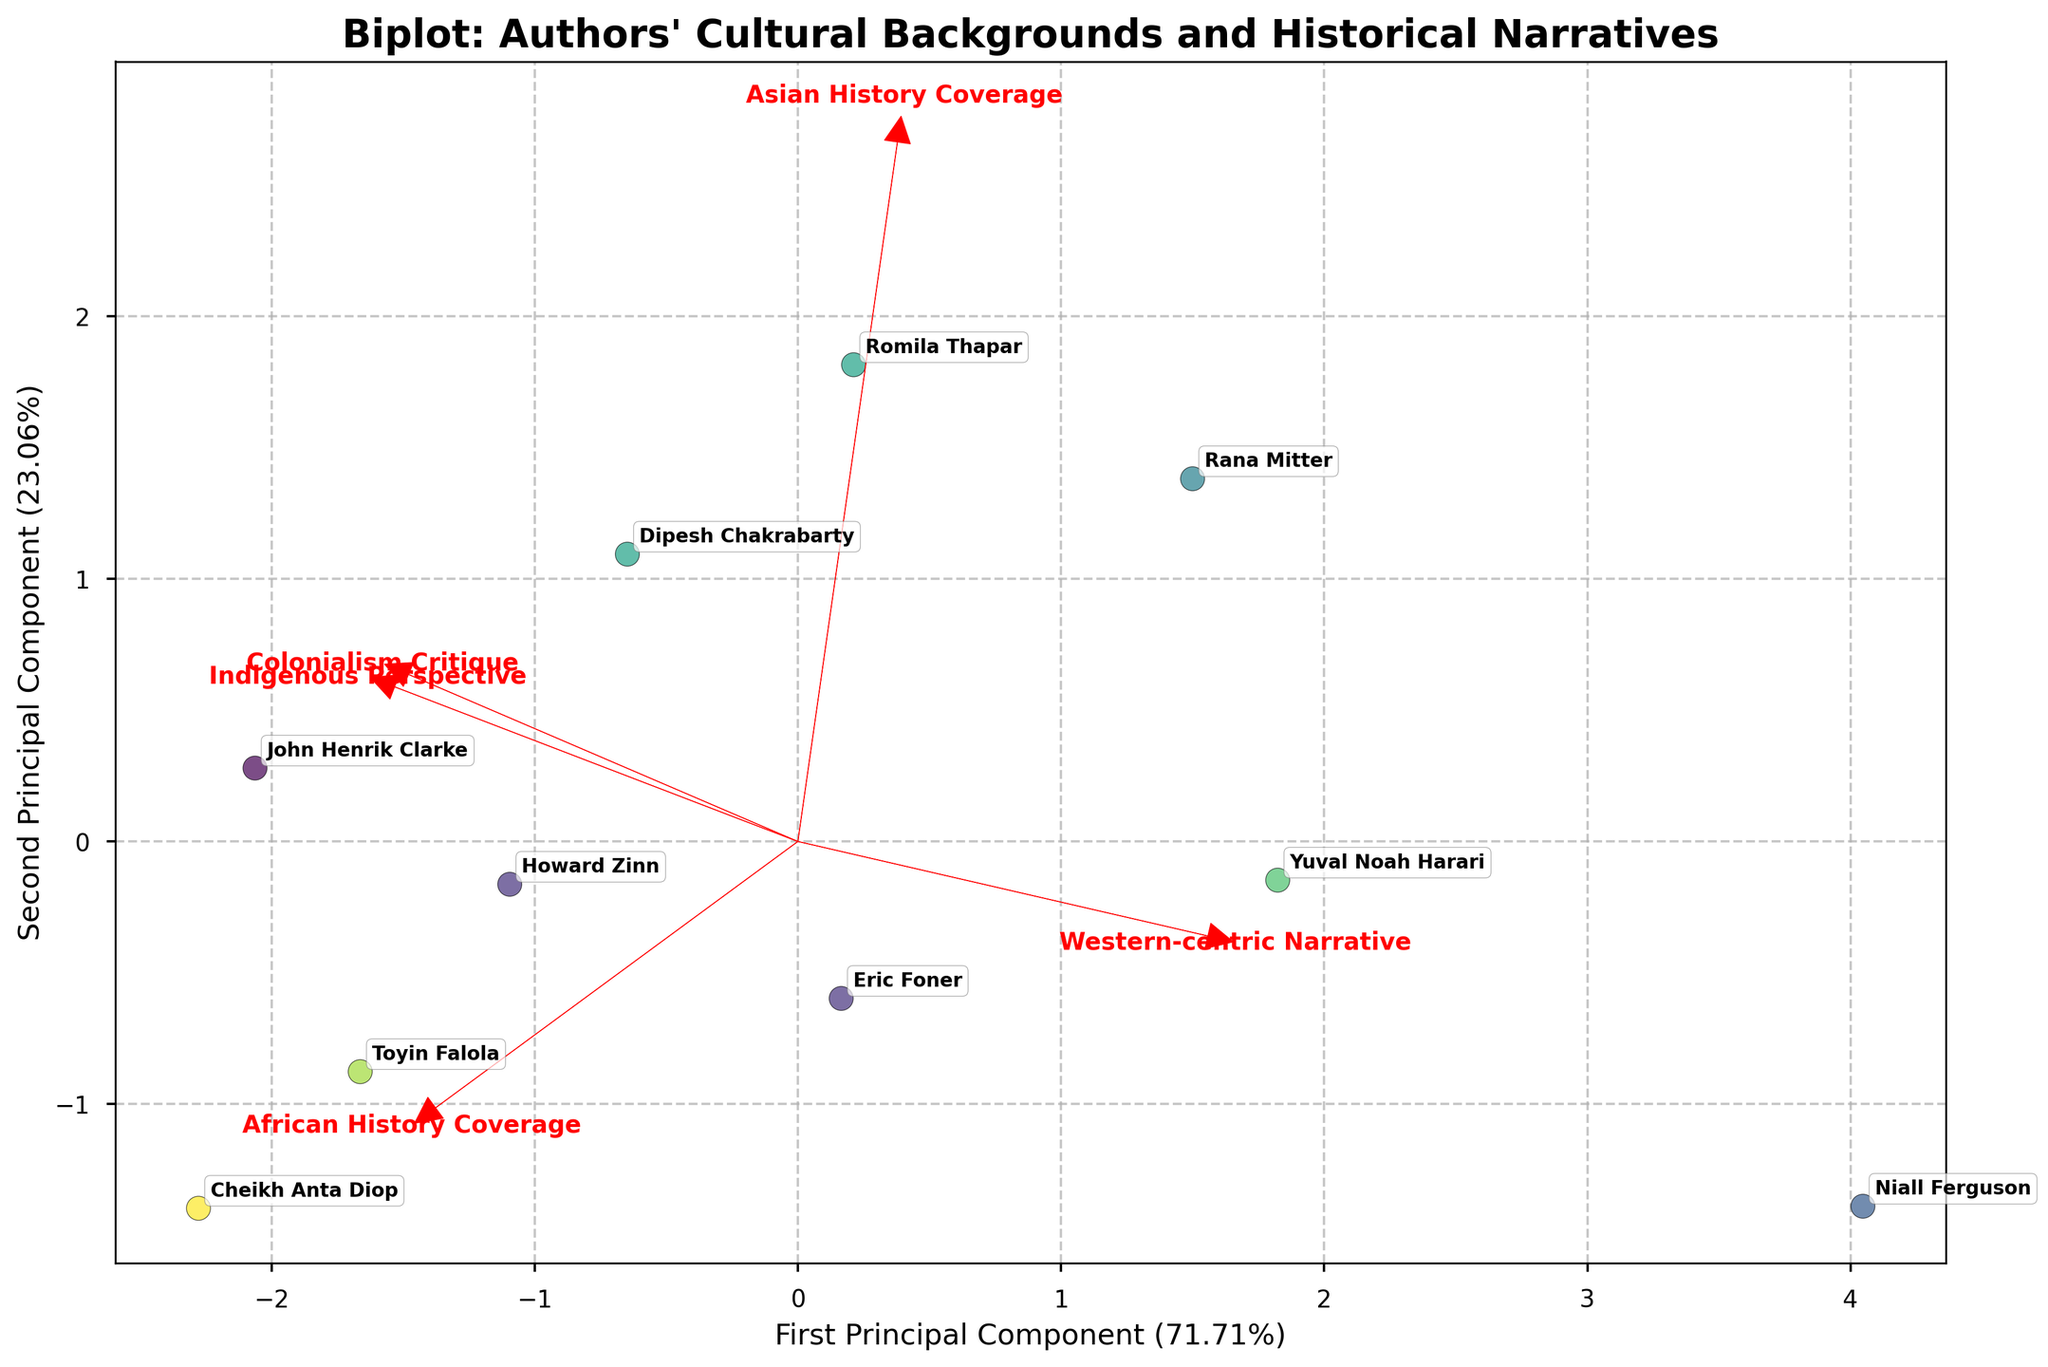Which author is closest to the center of the biplot? Eric Foner appears closest to the center as indicated by the PCA components on the plot. This suggests his narratives may balance various perspectives without significant skew towards a particular one.
Answer: Eric Foner How many authors have strong indigenous perspectives based on the biplot? Authors positioned near the vector representing "Indigenous Perspective" show stronger alignment with this perspective. Authors like Cheikh Anta Diop, Toyin Falola, John Henrik Clarke, and Dipesh Chakrabarty are positioned closer, indicating their strong emphasis on indigenous perspectives.
Answer: Four Which author exhibits the most Western-centric narrative in the biplot? Niall Ferguson is positioned farthest along the direction of the "Western-centric Narrative" vector, indicating his stronger inclination towards Western-centric viewpoints in comparison to others.
Answer: Niall Ferguson What is the relationship between African History coverage and Western-centric narratives evident in the biplot? The "African History Coverage" and "Western-centric Narrative" vectors are nearly orthogonal, suggesting little to no correlation between these two aspects in the historical narratives of the authors.
Answer: Little or no correlation Between "African History Coverage" and "Colonialism Critique", which vector is positioned more closely to John Henrik Clarke? John Henrik Clarke is positioned closer to the "Colonialism Critique" vector than "African History Coverage", suggesting a stronger emphasis on critiquing colonialism in his narratives.
Answer: Colonialism Critique Compare Yuval Noah Harari and Romila Thapar in terms of their perspectives on colonialism and indigenous viewpoints. Yuval Noah Harari is closer to neither the "Colonialism Critique" nor the "Indigenous Perspective" vectors, while Romila Thapar lies much closer to both. Thus, Romila offers stronger perspectives on these themes compared to Harari.
Answer: Romila Thapar How does Cheikh Anta Diop's coverage of Asian History compare to his coverage of African History? Based on the biplot, Cheikh Anta Diop is positioned closer to the "African History Coverage" vector, indicating a stronger emphasis on African history. His position farther from the "Asian History Coverage" vector suggests less emphasis on Asian history.
Answer: More emphasis on African history Who among the authors provides the least critique of colonialism according to the biplot? Niall Ferguson is positioned furthest from the "Colonialism Critique" vector, indicating that his narratives contain the least critique of colonialism among the authors.
Answer: Niall Ferguson Based on the biplot, which two authors show similar perspectives in their narratives? Howard Zinn and John Henrik Clarke appear close to each other on the biplot, suggesting similar perspectives especially in their anti-colonialist and indigenous viewpoint elements.
Answer: Howard Zinn and John Henrik Clarke Are there any authors who balance the coverage of African and Asian histories equally? Yuval Noah Harari and Romila Thapar appear positioned between vectors representing "African History Coverage" and "Asian History Coverage", suggesting a balance in their narrative coverage of these regions.
Answer: Yuval Noah Harari and Romila Thapar 